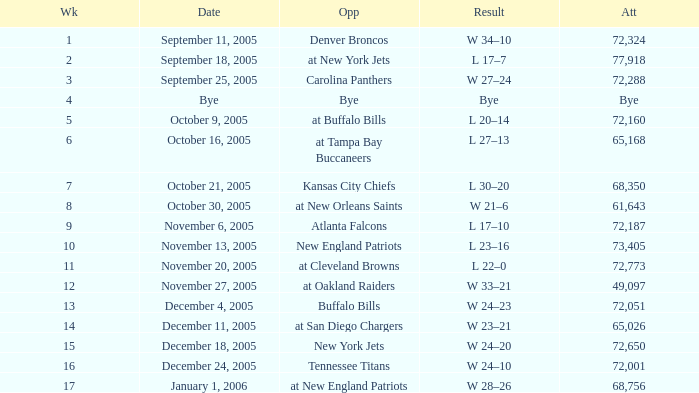In what Week was the Attendance 49,097? 12.0. 